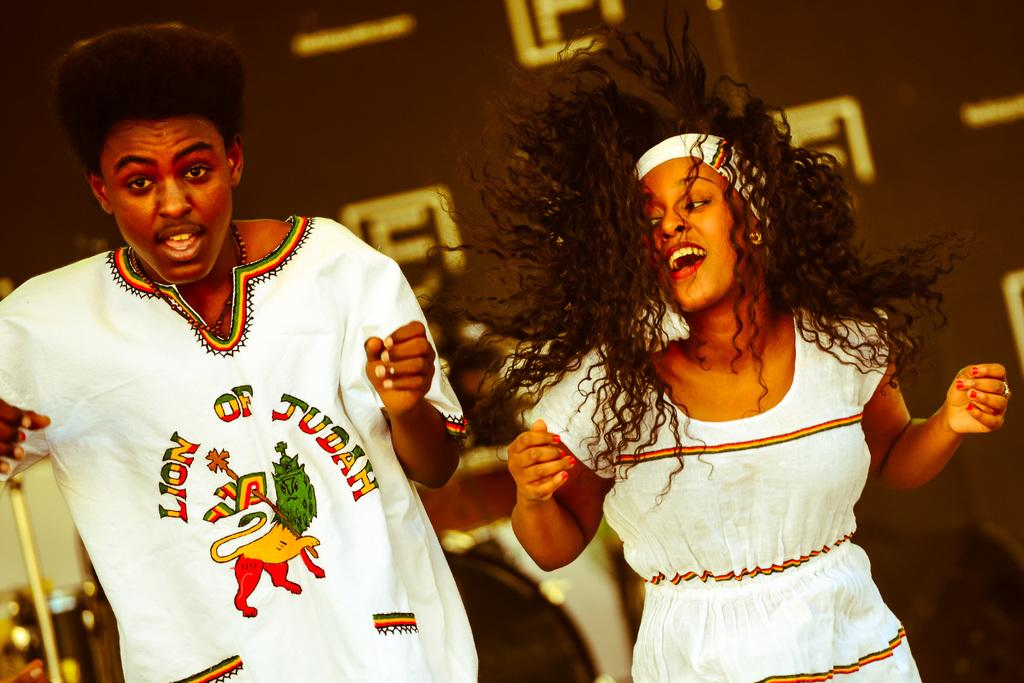How many people are in the image? There are two people in the image. What are the two people doing in the image? The two people are dancing. What religion is being practiced by the people in the image? There is no indication of any religious practice in the image; the two people are simply dancing. 